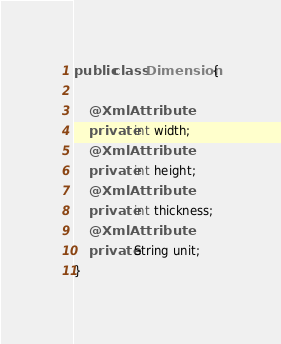Convert code to text. <code><loc_0><loc_0><loc_500><loc_500><_Java_>public class Dimension {

    @XmlAttribute
    private int width;
    @XmlAttribute
    private int height;
    @XmlAttribute
    private int thickness;
    @XmlAttribute
    private String unit;
}
</code> 